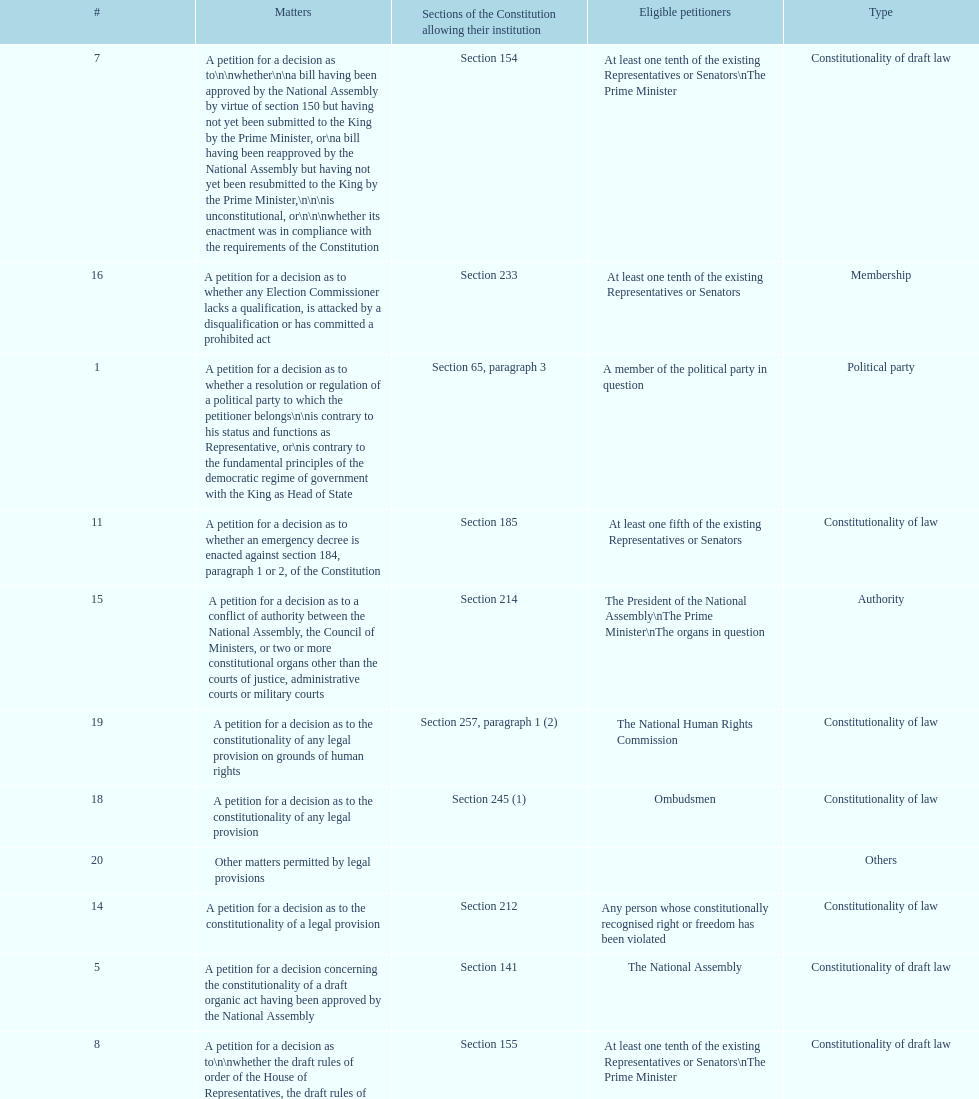How many matters have political party as their "type"? 3. 